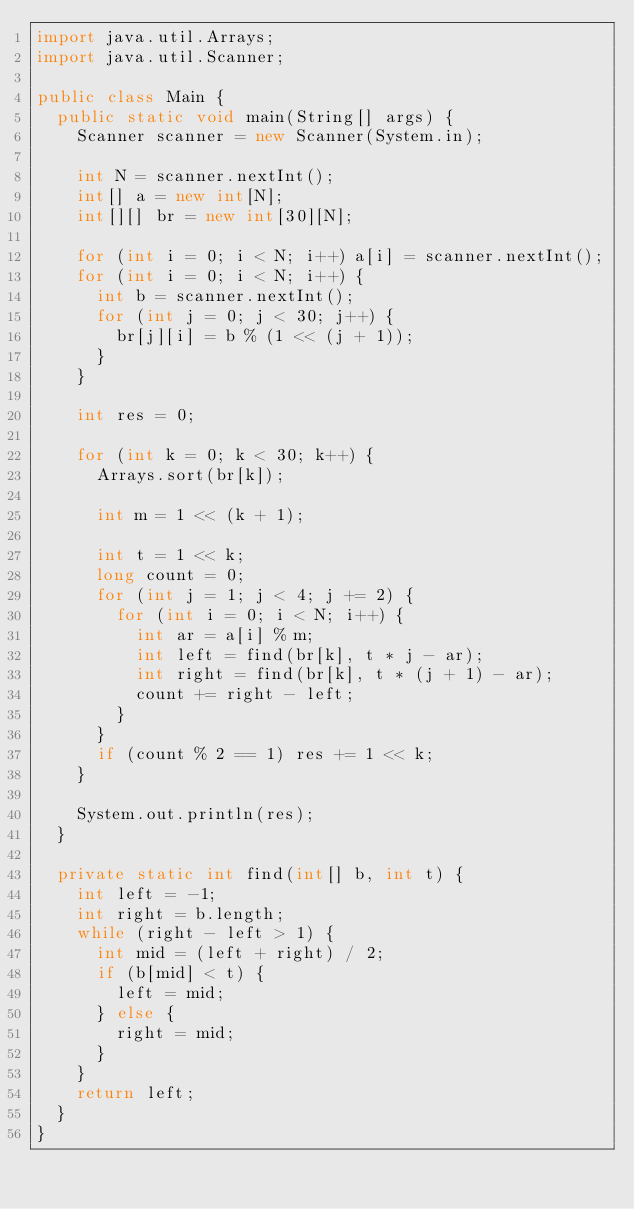<code> <loc_0><loc_0><loc_500><loc_500><_Java_>import java.util.Arrays;
import java.util.Scanner;

public class Main {
  public static void main(String[] args) {
    Scanner scanner = new Scanner(System.in);

    int N = scanner.nextInt();
    int[] a = new int[N];
    int[][] br = new int[30][N];

    for (int i = 0; i < N; i++) a[i] = scanner.nextInt();
    for (int i = 0; i < N; i++) {
      int b = scanner.nextInt();
      for (int j = 0; j < 30; j++) {
        br[j][i] = b % (1 << (j + 1));
      }
    }

    int res = 0;

    for (int k = 0; k < 30; k++) {
      Arrays.sort(br[k]);
      
      int m = 1 << (k + 1);

      int t = 1 << k;
      long count = 0;
      for (int j = 1; j < 4; j += 2) {
        for (int i = 0; i < N; i++) {
          int ar = a[i] % m;
          int left = find(br[k], t * j - ar);
          int right = find(br[k], t * (j + 1) - ar);
          count += right - left;
        }
      }
      if (count % 2 == 1) res += 1 << k;
    }

    System.out.println(res);
  }

  private static int find(int[] b, int t) {
    int left = -1;
    int right = b.length;
    while (right - left > 1) {
      int mid = (left + right) / 2;
      if (b[mid] < t) {
        left = mid;
      } else {
        right = mid;
      }
    }
    return left;
  }
}
</code> 